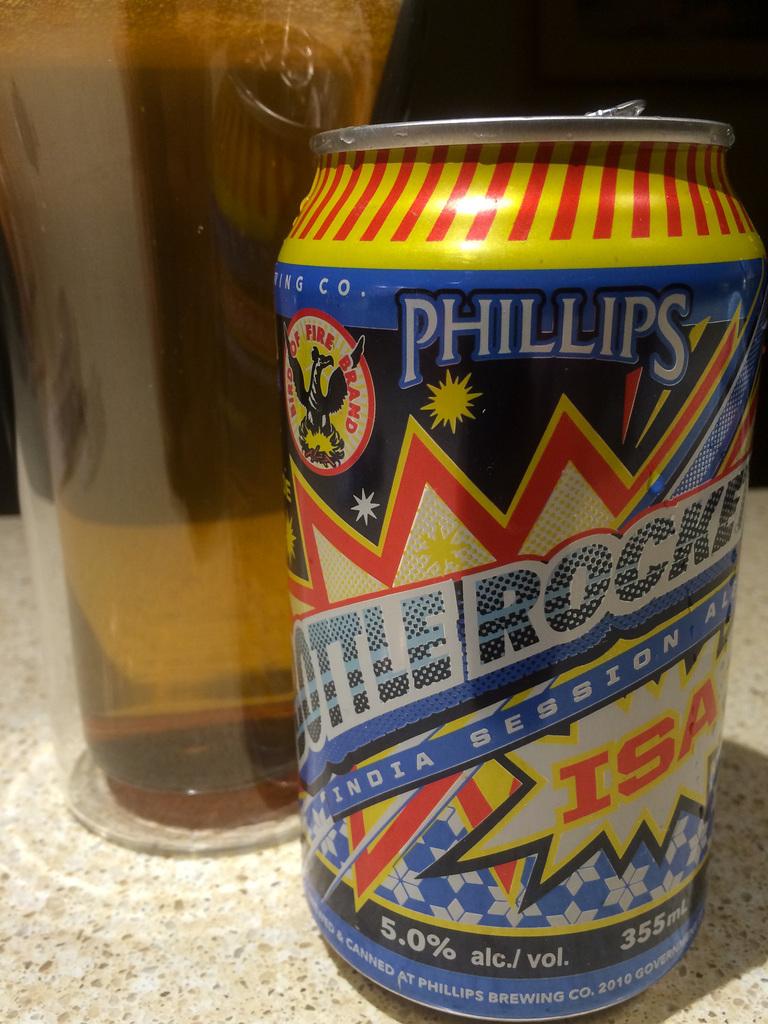What is in the can?
Your answer should be compact. Beer. 